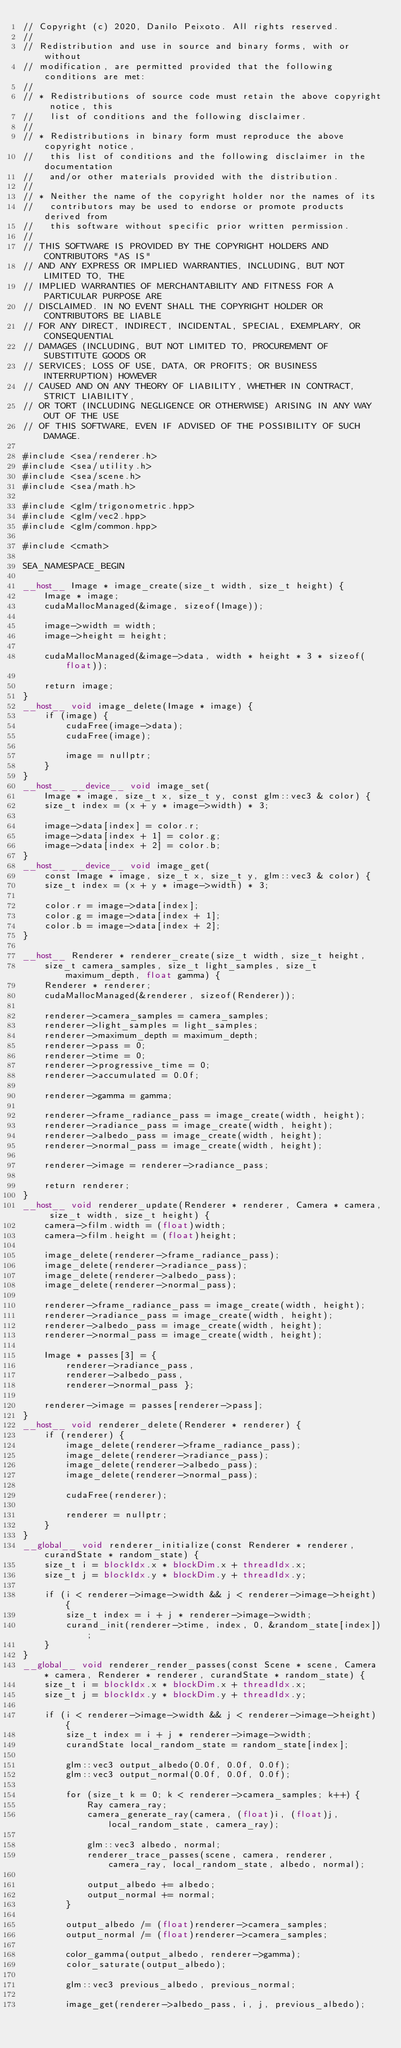Convert code to text. <code><loc_0><loc_0><loc_500><loc_500><_Cuda_>// Copyright (c) 2020, Danilo Peixoto. All rights reserved.
//
// Redistribution and use in source and binary forms, with or without
// modification, are permitted provided that the following conditions are met:
//
// * Redistributions of source code must retain the above copyright notice, this
//   list of conditions and the following disclaimer.
//
// * Redistributions in binary form must reproduce the above copyright notice,
//   this list of conditions and the following disclaimer in the documentation
//   and/or other materials provided with the distribution.
//
// * Neither the name of the copyright holder nor the names of its
//   contributors may be used to endorse or promote products derived from
//   this software without specific prior written permission.
//
// THIS SOFTWARE IS PROVIDED BY THE COPYRIGHT HOLDERS AND CONTRIBUTORS "AS IS"
// AND ANY EXPRESS OR IMPLIED WARRANTIES, INCLUDING, BUT NOT LIMITED TO, THE
// IMPLIED WARRANTIES OF MERCHANTABILITY AND FITNESS FOR A PARTICULAR PURPOSE ARE
// DISCLAIMED. IN NO EVENT SHALL THE COPYRIGHT HOLDER OR CONTRIBUTORS BE LIABLE
// FOR ANY DIRECT, INDIRECT, INCIDENTAL, SPECIAL, EXEMPLARY, OR CONSEQUENTIAL
// DAMAGES (INCLUDING, BUT NOT LIMITED TO, PROCUREMENT OF SUBSTITUTE GOODS OR
// SERVICES; LOSS OF USE, DATA, OR PROFITS; OR BUSINESS INTERRUPTION) HOWEVER
// CAUSED AND ON ANY THEORY OF LIABILITY, WHETHER IN CONTRACT, STRICT LIABILITY,
// OR TORT (INCLUDING NEGLIGENCE OR OTHERWISE) ARISING IN ANY WAY OUT OF THE USE
// OF THIS SOFTWARE, EVEN IF ADVISED OF THE POSSIBILITY OF SUCH DAMAGE.

#include <sea/renderer.h>
#include <sea/utility.h>
#include <sea/scene.h>
#include <sea/math.h>

#include <glm/trigonometric.hpp>
#include <glm/vec2.hpp>
#include <glm/common.hpp>

#include <cmath>

SEA_NAMESPACE_BEGIN

__host__ Image * image_create(size_t width, size_t height) {
    Image * image;
    cudaMallocManaged(&image, sizeof(Image));

    image->width = width;
    image->height = height;

    cudaMallocManaged(&image->data, width * height * 3 * sizeof(float));

    return image;
}
__host__ void image_delete(Image * image) {
    if (image) {
        cudaFree(image->data);
        cudaFree(image);

        image = nullptr;
    }
}
__host__ __device__ void image_set(
    Image * image, size_t x, size_t y, const glm::vec3 & color) {
    size_t index = (x + y * image->width) * 3;

    image->data[index] = color.r;
    image->data[index + 1] = color.g;
    image->data[index + 2] = color.b;
}
__host__ __device__ void image_get(
    const Image * image, size_t x, size_t y, glm::vec3 & color) {
    size_t index = (x + y * image->width) * 3;

    color.r = image->data[index];
    color.g = image->data[index + 1];
    color.b = image->data[index + 2];
}

__host__ Renderer * renderer_create(size_t width, size_t height,
    size_t camera_samples, size_t light_samples, size_t maximum_depth, float gamma) {
    Renderer * renderer;
    cudaMallocManaged(&renderer, sizeof(Renderer));

    renderer->camera_samples = camera_samples;
    renderer->light_samples = light_samples;
    renderer->maximum_depth = maximum_depth;
	renderer->pass = 0;
    renderer->time = 0;
    renderer->progressive_time = 0;
    renderer->accumulated = 0.0f;

    renderer->gamma = gamma;

	renderer->frame_radiance_pass = image_create(width, height);
    renderer->radiance_pass = image_create(width, height);
	renderer->albedo_pass = image_create(width, height);
	renderer->normal_pass = image_create(width, height);

	renderer->image = renderer->radiance_pass;

    return renderer;
}
__host__ void renderer_update(Renderer * renderer, Camera * camera, size_t width, size_t height) {
	camera->film.width = (float)width;
    camera->film.height = (float)height;

	image_delete(renderer->frame_radiance_pass);
    image_delete(renderer->radiance_pass);
	image_delete(renderer->albedo_pass);
	image_delete(renderer->normal_pass);

	renderer->frame_radiance_pass = image_create(width, height);
	renderer->radiance_pass = image_create(width, height);
	renderer->albedo_pass = image_create(width, height);
	renderer->normal_pass = image_create(width, height);

	Image * passes[3] = {
		renderer->radiance_pass,
		renderer->albedo_pass,
		renderer->normal_pass };

	renderer->image = passes[renderer->pass];
}
__host__ void renderer_delete(Renderer * renderer) {
    if (renderer) {
		image_delete(renderer->frame_radiance_pass);
        image_delete(renderer->radiance_pass);
		image_delete(renderer->albedo_pass);
		image_delete(renderer->normal_pass);

        cudaFree(renderer);

        renderer = nullptr;
    }
}
__global__ void renderer_initialize(const Renderer * renderer, curandState * random_state) {
	size_t i = blockIdx.x * blockDim.x + threadIdx.x;
	size_t j = blockIdx.y * blockDim.y + threadIdx.y;

	if (i < renderer->image->width && j < renderer->image->height) {
		size_t index = i + j * renderer->image->width;
		curand_init(renderer->time, index, 0, &random_state[index]);
	}
}
__global__ void renderer_render_passes(const Scene * scene, Camera * camera, Renderer * renderer, curandState * random_state) {
	size_t i = blockIdx.x * blockDim.x + threadIdx.x;
	size_t j = blockIdx.y * blockDim.y + threadIdx.y;

	if (i < renderer->image->width && j < renderer->image->height) {
		size_t index = i + j * renderer->image->width;
		curandState local_random_state = random_state[index];

		glm::vec3 output_albedo(0.0f, 0.0f, 0.0f);
		glm::vec3 output_normal(0.0f, 0.0f, 0.0f);

		for (size_t k = 0; k < renderer->camera_samples; k++) {
			Ray camera_ray;
			camera_generate_ray(camera, (float)i, (float)j, local_random_state, camera_ray);

			glm::vec3 albedo, normal;
			renderer_trace_passes(scene, camera, renderer, camera_ray, local_random_state, albedo, normal);

			output_albedo += albedo;
			output_normal += normal;
		}

		output_albedo /= (float)renderer->camera_samples;
		output_normal /= (float)renderer->camera_samples;

		color_gamma(output_albedo, renderer->gamma);
		color_saturate(output_albedo);

		glm::vec3 previous_albedo, previous_normal;

		image_get(renderer->albedo_pass, i, j, previous_albedo);</code> 